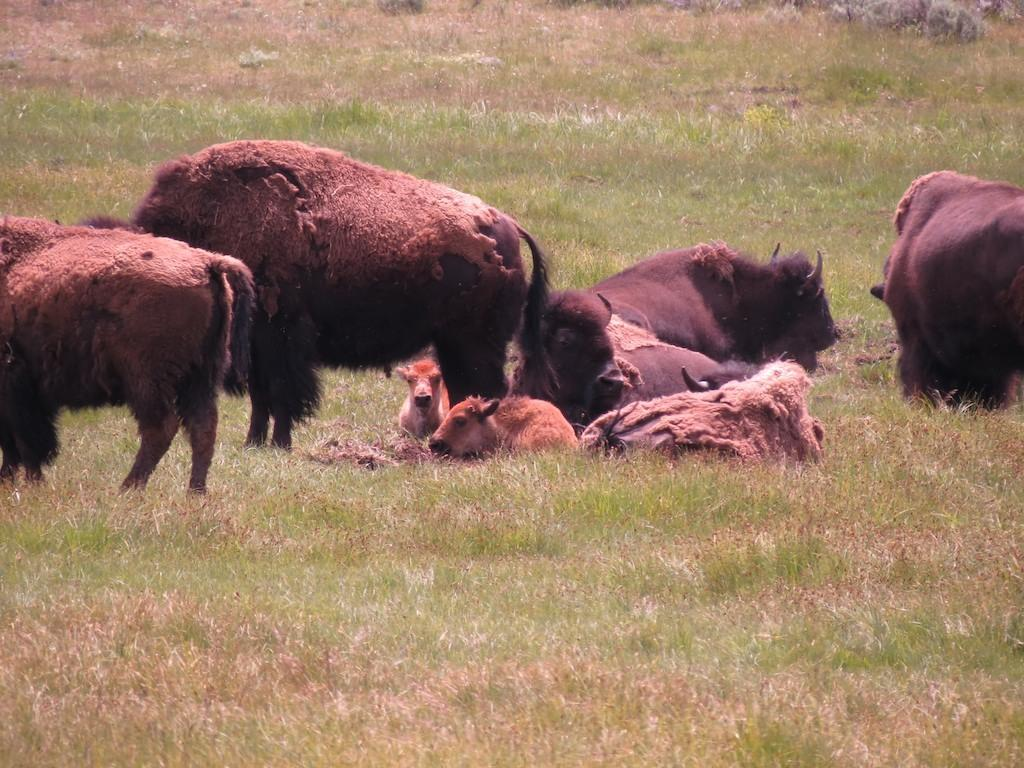What is located in the foreground of the image? There are animals in the foreground of the image. What is the surface on which the animals are standing? The animals are on the grass. What type of hands can be seen holding the animals in the image? There are no hands visible in the image, and the animals are not being held. What nation is represented by the animals in the image? The image does not represent any specific nation, as it only shows animals on grass. 